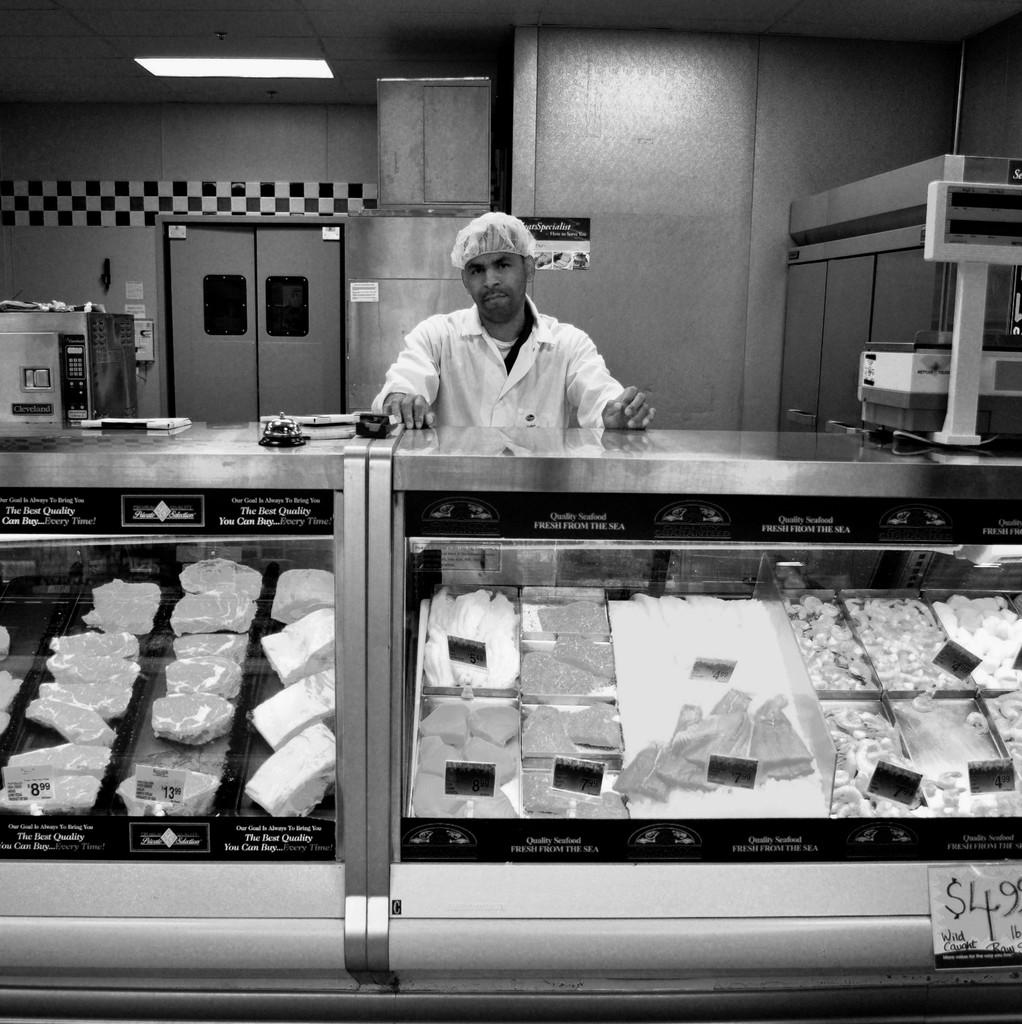Provide a one-sentence caption for the provided image. A butcher stands behind the counter with a pricetag stating $4.99 per pound for some meat. 